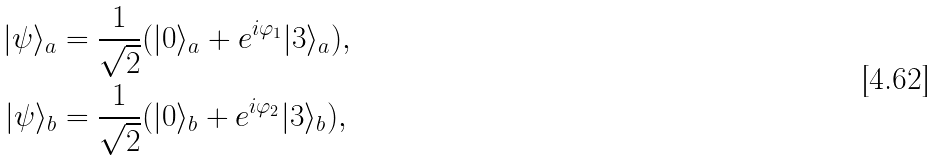Convert formula to latex. <formula><loc_0><loc_0><loc_500><loc_500>| \psi \rangle _ { a } & = \frac { 1 } { \sqrt { 2 } } ( | 0 \rangle _ { a } + e ^ { i \varphi _ { 1 } } | 3 \rangle _ { a } ) , \\ | \psi \rangle _ { b } & = \frac { 1 } { \sqrt { 2 } } ( | 0 \rangle _ { b } + e ^ { i \varphi _ { 2 } } | 3 \rangle _ { b } ) ,</formula> 